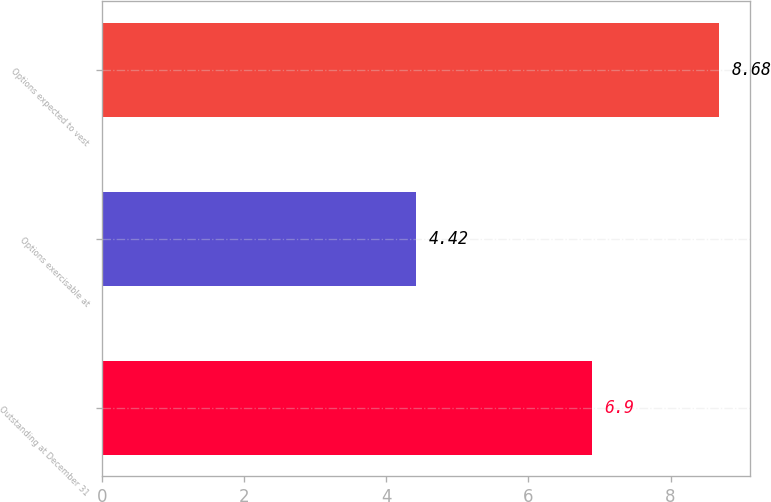Convert chart to OTSL. <chart><loc_0><loc_0><loc_500><loc_500><bar_chart><fcel>Outstanding at December 31<fcel>Options exercisable at<fcel>Options expected to vest<nl><fcel>6.9<fcel>4.42<fcel>8.68<nl></chart> 